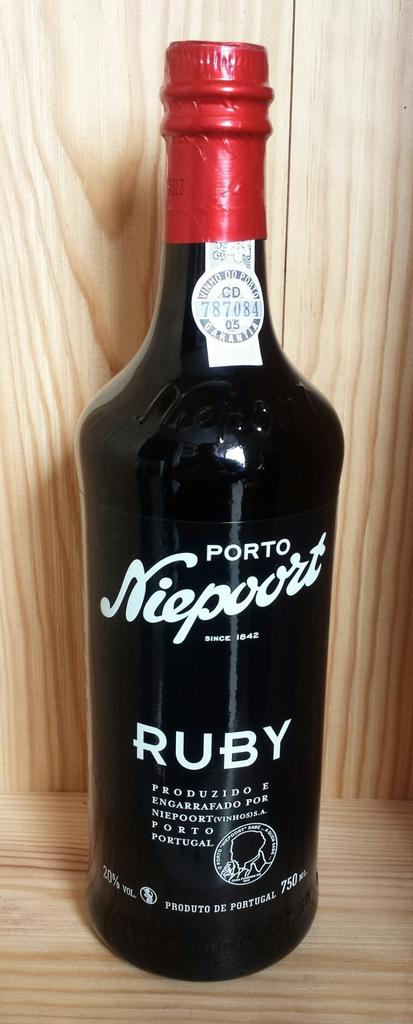Provide a one-sentence caption for the provided image. A bottle of Porto Niepoort wine on a wooden shelf. 